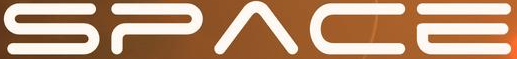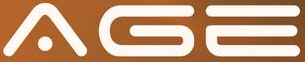Transcribe the words shown in these images in order, separated by a semicolon. SPACE; AGE 